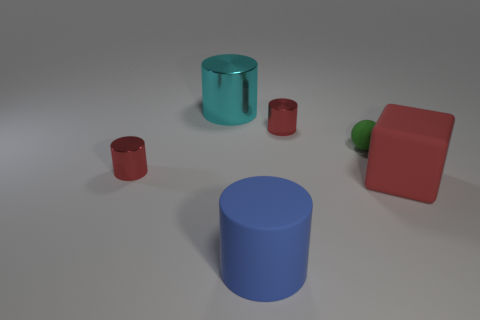Subtract all blue cylinders. How many cylinders are left? 3 Subtract all large blue cylinders. How many cylinders are left? 3 Add 3 red objects. How many objects exist? 9 Subtract all gray cylinders. Subtract all purple spheres. How many cylinders are left? 4 Subtract all cylinders. How many objects are left? 2 Subtract all rubber cylinders. Subtract all large red cubes. How many objects are left? 4 Add 6 cyan shiny cylinders. How many cyan shiny cylinders are left? 7 Add 4 cyan shiny cylinders. How many cyan shiny cylinders exist? 5 Subtract 0 green cylinders. How many objects are left? 6 